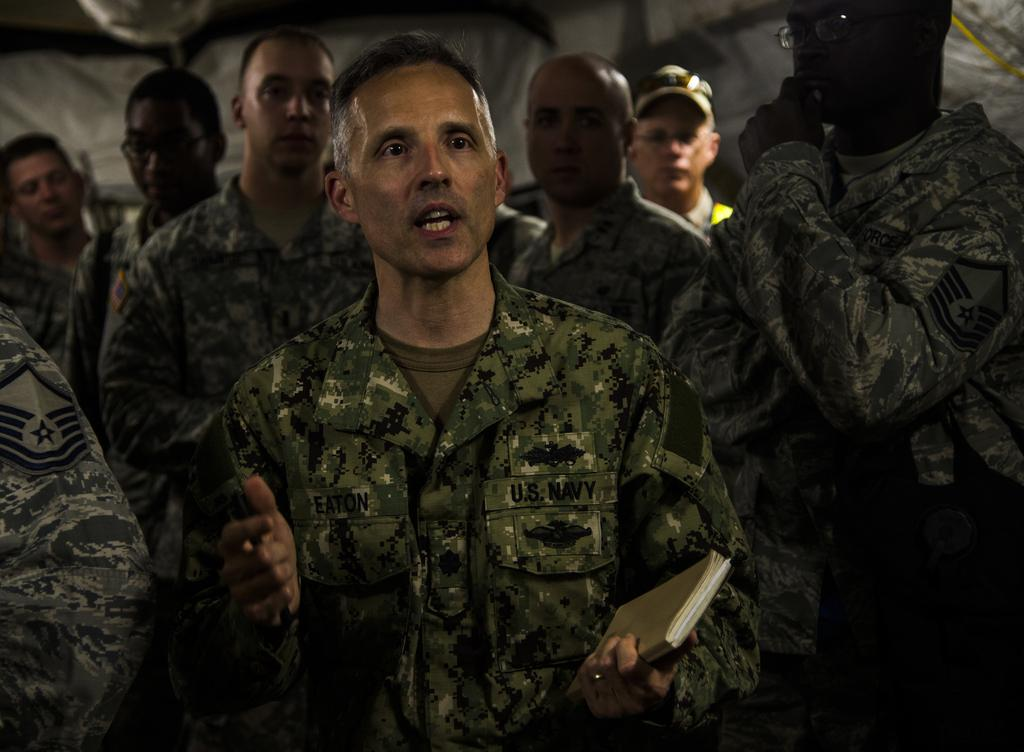What can be observed about the people in the image? There are people standing in the image, and they are wearing uniforms. Can you describe the arrangement of the people in the image? The people are standing in a group, and a man is standing in the center of the group. What is the man in the center holding? The man in the center is holding a book. How does the feeling of the organization affect the temper of the people in the image? There is no information about the organization's feeling or the people's temper in the image. The image only shows people standing in uniforms, with a man holding a book. 